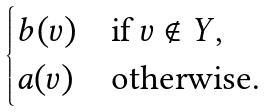<formula> <loc_0><loc_0><loc_500><loc_500>\begin{cases} b ( v ) & \text {if } v \notin Y , \\ a ( v ) & \text {otherwise.} \end{cases}</formula> 